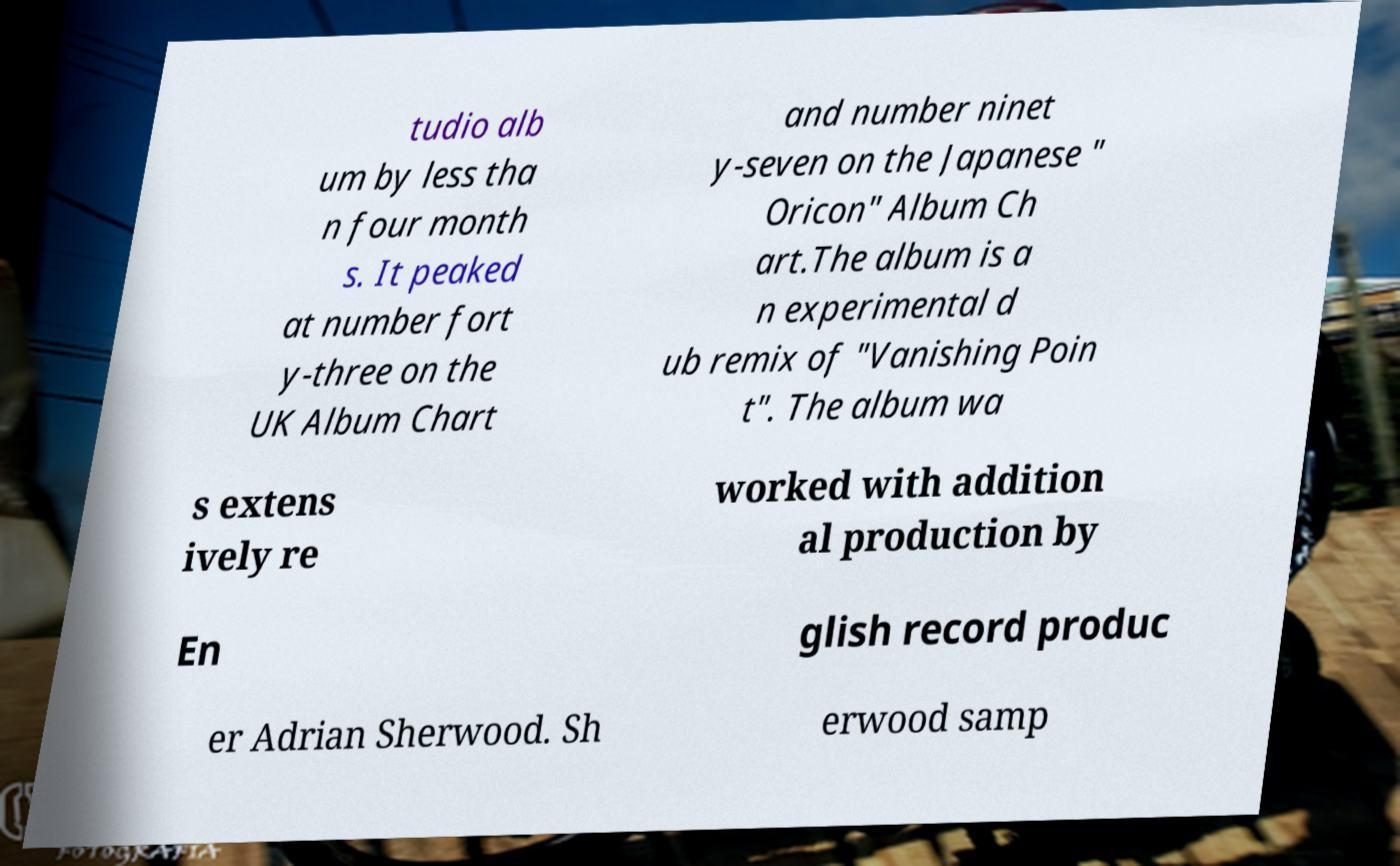Can you accurately transcribe the text from the provided image for me? tudio alb um by less tha n four month s. It peaked at number fort y-three on the UK Album Chart and number ninet y-seven on the Japanese " Oricon" Album Ch art.The album is a n experimental d ub remix of "Vanishing Poin t". The album wa s extens ively re worked with addition al production by En glish record produc er Adrian Sherwood. Sh erwood samp 